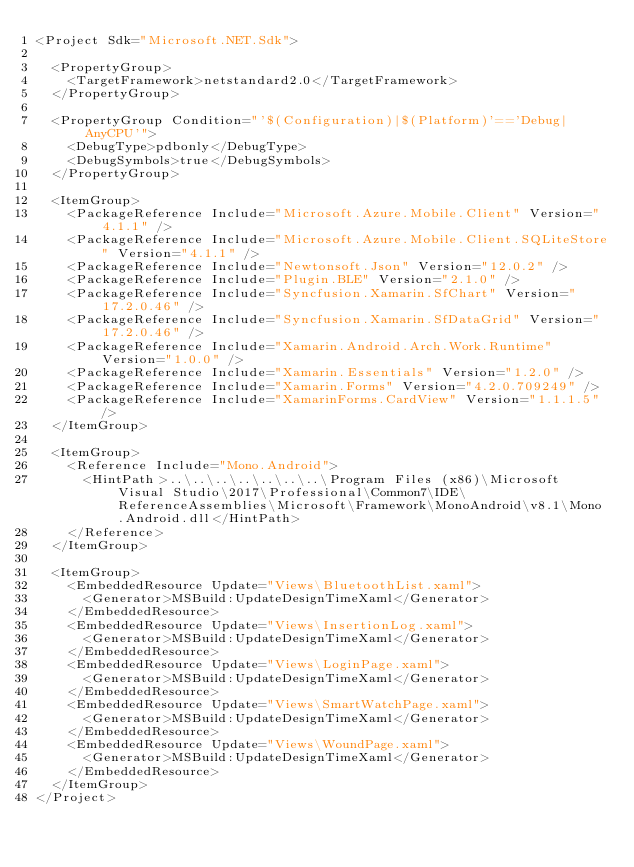<code> <loc_0><loc_0><loc_500><loc_500><_XML_><Project Sdk="Microsoft.NET.Sdk">

  <PropertyGroup>
    <TargetFramework>netstandard2.0</TargetFramework>
  </PropertyGroup>

  <PropertyGroup Condition="'$(Configuration)|$(Platform)'=='Debug|AnyCPU'">
    <DebugType>pdbonly</DebugType>
    <DebugSymbols>true</DebugSymbols>
  </PropertyGroup>

  <ItemGroup>
    <PackageReference Include="Microsoft.Azure.Mobile.Client" Version="4.1.1" />
    <PackageReference Include="Microsoft.Azure.Mobile.Client.SQLiteStore" Version="4.1.1" />
    <PackageReference Include="Newtonsoft.Json" Version="12.0.2" />
    <PackageReference Include="Plugin.BLE" Version="2.1.0" />
    <PackageReference Include="Syncfusion.Xamarin.SfChart" Version="17.2.0.46" />
    <PackageReference Include="Syncfusion.Xamarin.SfDataGrid" Version="17.2.0.46" />
    <PackageReference Include="Xamarin.Android.Arch.Work.Runtime" Version="1.0.0" />
    <PackageReference Include="Xamarin.Essentials" Version="1.2.0" />
    <PackageReference Include="Xamarin.Forms" Version="4.2.0.709249" />
    <PackageReference Include="XamarinForms.CardView" Version="1.1.1.5" />  
  </ItemGroup>

  <ItemGroup>
    <Reference Include="Mono.Android">
      <HintPath>..\..\..\..\..\..\..\Program Files (x86)\Microsoft Visual Studio\2017\Professional\Common7\IDE\ReferenceAssemblies\Microsoft\Framework\MonoAndroid\v8.1\Mono.Android.dll</HintPath>
    </Reference>
  </ItemGroup>

  <ItemGroup>
    <EmbeddedResource Update="Views\BluetoothList.xaml">
      <Generator>MSBuild:UpdateDesignTimeXaml</Generator>
    </EmbeddedResource>
    <EmbeddedResource Update="Views\InsertionLog.xaml">
      <Generator>MSBuild:UpdateDesignTimeXaml</Generator>
    </EmbeddedResource>
    <EmbeddedResource Update="Views\LoginPage.xaml">
      <Generator>MSBuild:UpdateDesignTimeXaml</Generator>
    </EmbeddedResource>
    <EmbeddedResource Update="Views\SmartWatchPage.xaml">
      <Generator>MSBuild:UpdateDesignTimeXaml</Generator>
    </EmbeddedResource>
    <EmbeddedResource Update="Views\WoundPage.xaml">
      <Generator>MSBuild:UpdateDesignTimeXaml</Generator>
    </EmbeddedResource>
  </ItemGroup>
</Project></code> 